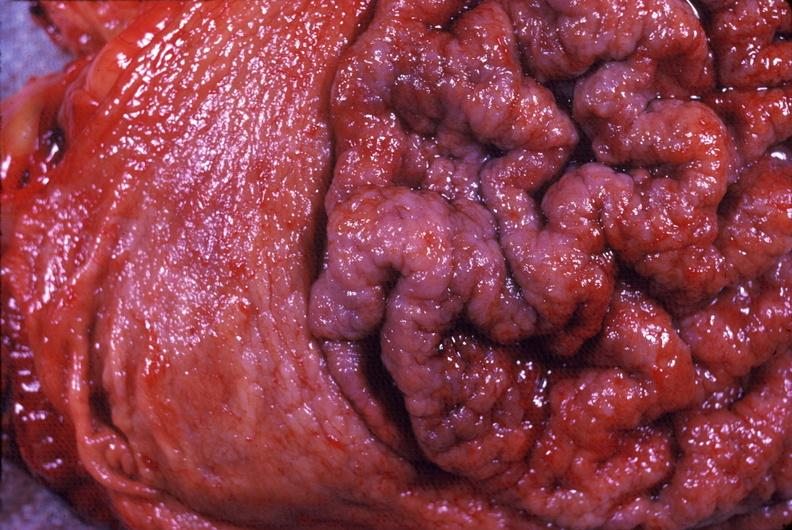what does this image show?
Answer the question using a single word or phrase. Stomach 